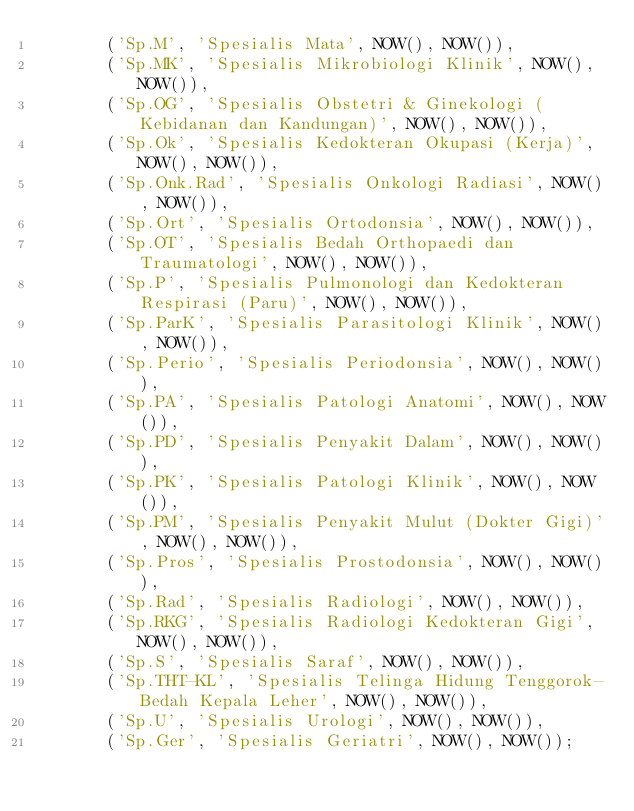<code> <loc_0><loc_0><loc_500><loc_500><_SQL_>       ('Sp.M', 'Spesialis Mata', NOW(), NOW()),
       ('Sp.MK', 'Spesialis Mikrobiologi Klinik', NOW(), NOW()),
       ('Sp.OG', 'Spesialis Obstetri & Ginekologi (Kebidanan dan Kandungan)', NOW(), NOW()),
       ('Sp.Ok', 'Spesialis Kedokteran Okupasi (Kerja)', NOW(), NOW()),
       ('Sp.Onk.Rad', 'Spesialis Onkologi Radiasi', NOW(), NOW()),
       ('Sp.Ort', 'Spesialis Ortodonsia', NOW(), NOW()),
       ('Sp.OT', 'Spesialis Bedah Orthopaedi dan Traumatologi', NOW(), NOW()),
       ('Sp.P', 'Spesialis Pulmonologi dan Kedokteran Respirasi (Paru)', NOW(), NOW()),
       ('Sp.ParK', 'Spesialis Parasitologi Klinik', NOW(), NOW()),
       ('Sp.Perio', 'Spesialis Periodonsia', NOW(), NOW()),
       ('Sp.PA', 'Spesialis Patologi Anatomi', NOW(), NOW()),
       ('Sp.PD', 'Spesialis Penyakit Dalam', NOW(), NOW()),
       ('Sp.PK', 'Spesialis Patologi Klinik', NOW(), NOW()),
       ('Sp.PM', 'Spesialis Penyakit Mulut (Dokter Gigi)', NOW(), NOW()),
       ('Sp.Pros', 'Spesialis Prostodonsia', NOW(), NOW()),
       ('Sp.Rad', 'Spesialis Radiologi', NOW(), NOW()),
       ('Sp.RKG', 'Spesialis Radiologi Kedokteran Gigi', NOW(), NOW()),
       ('Sp.S', 'Spesialis Saraf', NOW(), NOW()),
       ('Sp.THT-KL', 'Spesialis Telinga Hidung Tenggorok-Bedah Kepala Leher', NOW(), NOW()),
       ('Sp.U', 'Spesialis Urologi', NOW(), NOW()),
       ('Sp.Ger', 'Spesialis Geriatri', NOW(), NOW());
</code> 